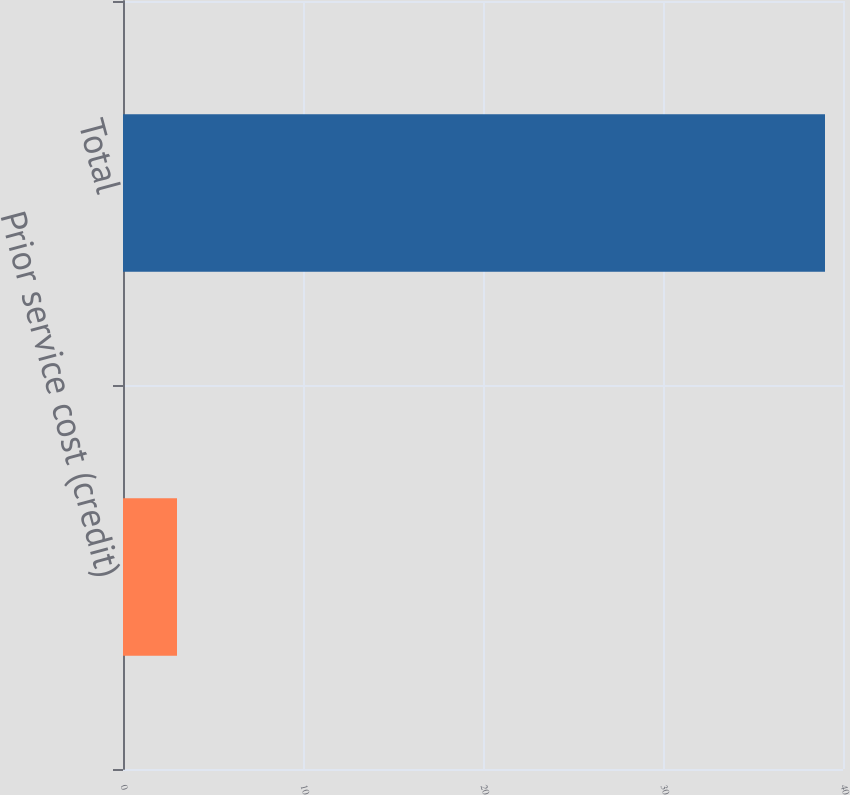Convert chart. <chart><loc_0><loc_0><loc_500><loc_500><bar_chart><fcel>Prior service cost (credit)<fcel>Total<nl><fcel>3<fcel>39<nl></chart> 